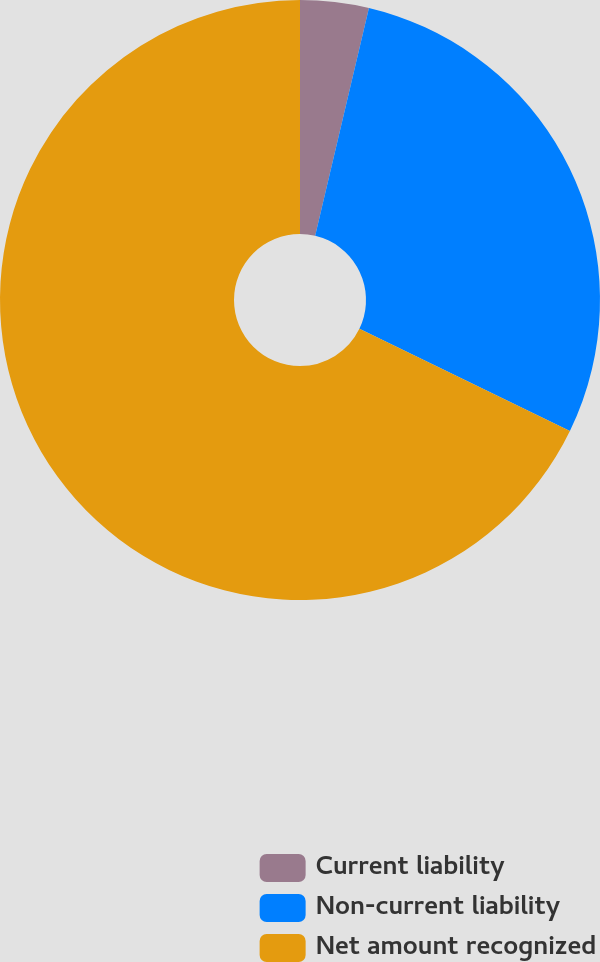Convert chart to OTSL. <chart><loc_0><loc_0><loc_500><loc_500><pie_chart><fcel>Current liability<fcel>Non-current liability<fcel>Net amount recognized<nl><fcel>3.69%<fcel>28.5%<fcel>67.81%<nl></chart> 